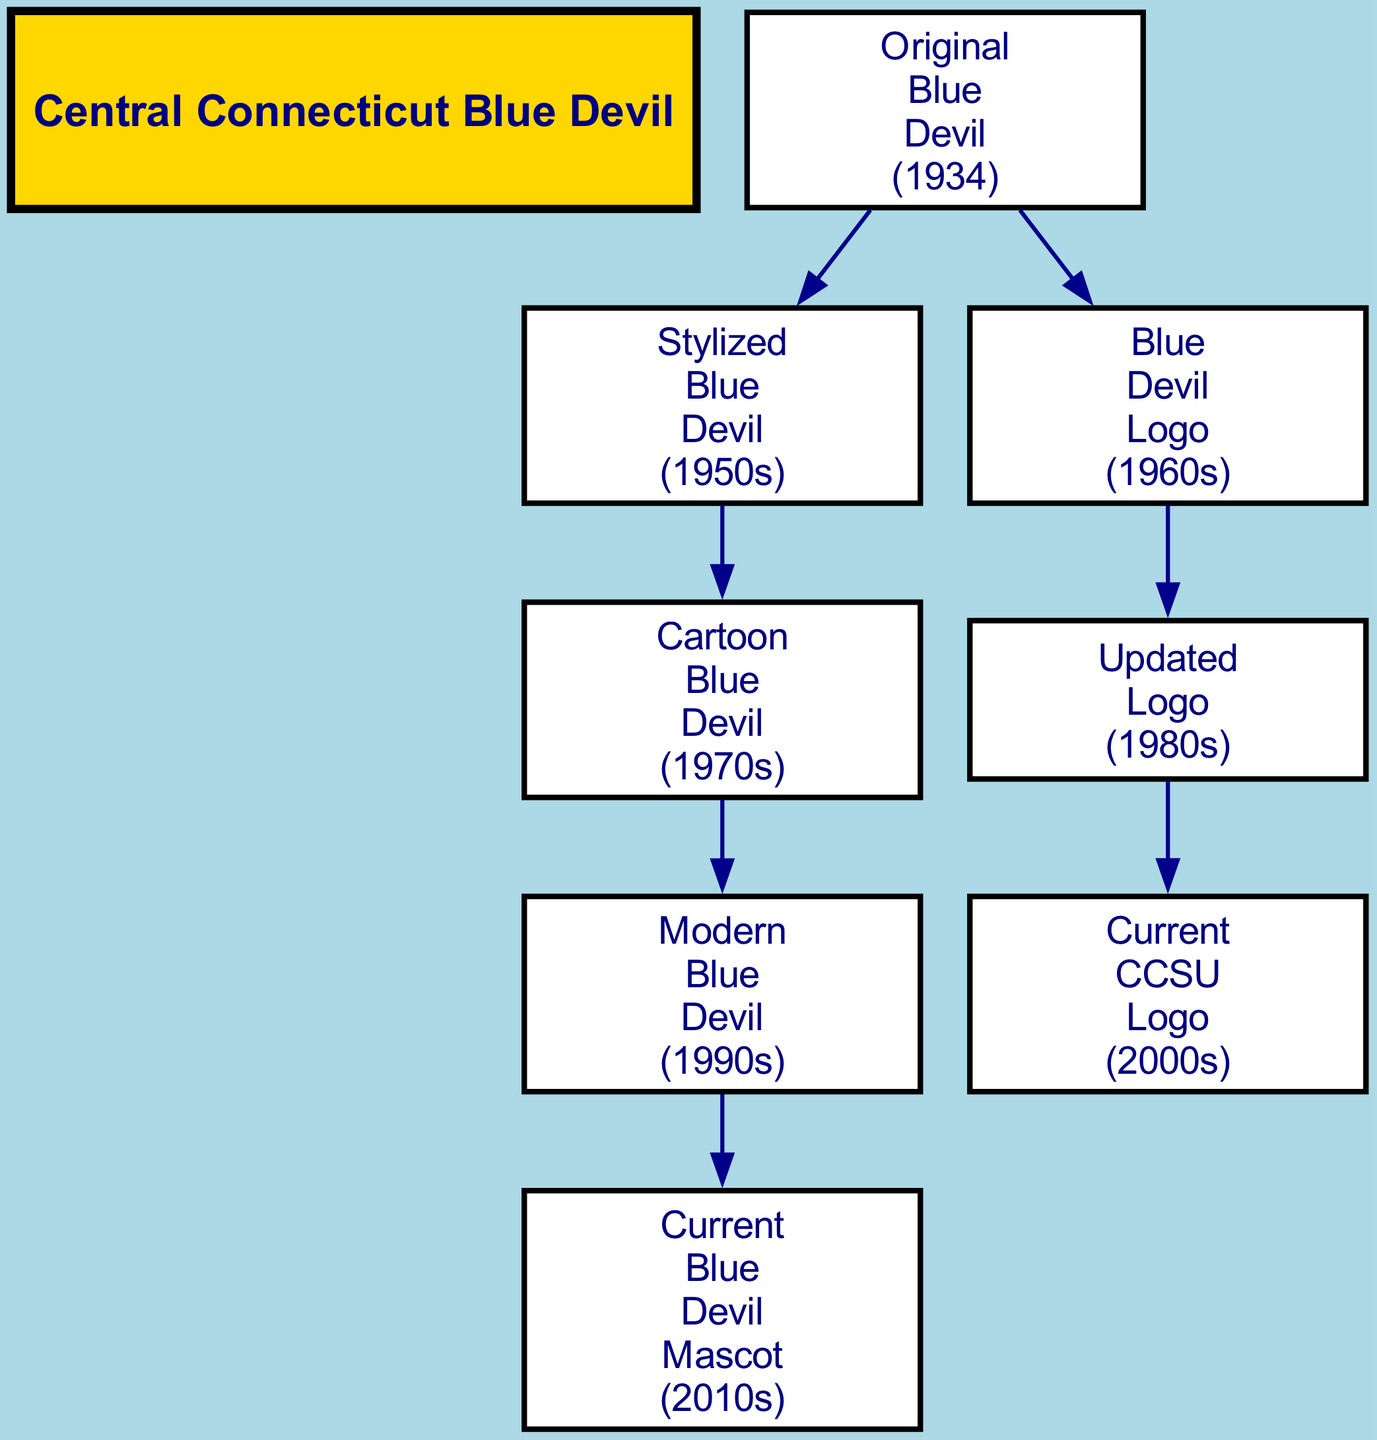What is the root of the family tree? The root is "Central Connecticut Blue Devil," which represents the starting point or the main character of the genealogical chart for the mascot.
Answer: Central Connecticut Blue Devil How many first-generation characters are there? There are two first-generation characters stemming from the "Original Blue Devil (1934)"—the "Stylized Blue Devil (1950s)" and the "Blue Devil Logo (1960s)."
Answer: 2 Which character represents the modern version of the mascot? The character that represents the modern version of the mascot is the "Current Blue Devil Mascot (2010s)," which shows the latest evolution in the design and concept of the mascot.
Answer: Current Blue Devil Mascot (2010s) What decade did the "Cartoon Blue Devil" emerge? The "Cartoon Blue Devil" emerged in the 1970s as part of the evolution of the mascot, showcasing a more animated and playful representation.
Answer: 1970s What is the relationship between the "Updated Logo (1980s)" and the "Blue Devil Logo (1960s)"? The "Updated Logo (1980s)" is a child of the "Blue Devil Logo (1960s)," indicating that the updated version is a direct evolution from the original logo created in the 1960s.
Answer: Child How many total generations are there depicted in the diagram? There are three total generations depicted in the diagram: the first generation starting from the "Original Blue Devil," the second generation including characters like the "Stylized Blue Devil" and "Blue Devil Logo," and the third generation showcasing modern characters.
Answer: 3 Which element is the earliest version of the mascot? The earliest version of the mascot is the "Original Blue Devil (1934)," representing the initial creation of the Blue Devil character.
Answer: Original Blue Devil (1934) How does the "Current CCSU Logo (2000s)" relate to the "Blue Devil Logo (1960s)"? The "Current CCSU Logo (2000s)" is a descendant of the "Blue Devil Logo (1960s)," indicating that it evolved from that previous design, which is a fundamental part of its lineage.
Answer: Descendant What is the direct predecessor of the "Modern Blue Devil (1990s)"? The direct predecessor of the "Modern Blue Devil (1990s)" is the "Cartoon Blue Devil (1970s)," showing the progression in the design leading up to modern iterations.
Answer: Cartoon Blue Devil (1970s) 